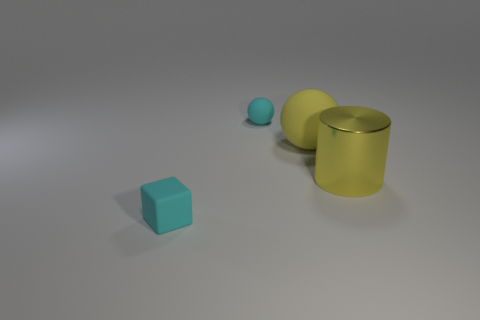Are there fewer big matte spheres that are to the right of the yellow rubber thing than cyan rubber cubes in front of the tiny block?
Give a very brief answer. No. Does the large yellow sphere have the same material as the tiny sphere?
Ensure brevity in your answer.  Yes. What size is the object that is both right of the small matte sphere and to the left of the shiny object?
Ensure brevity in your answer.  Large. The metal object that is the same size as the yellow matte ball is what shape?
Make the answer very short. Cylinder. What is the material of the cyan object in front of the tiny thing that is behind the rubber thing in front of the yellow rubber object?
Offer a terse response. Rubber. There is a cyan object that is in front of the large shiny object; is its shape the same as the tiny cyan rubber thing that is behind the small cube?
Provide a succinct answer. No. How many other things are the same material as the yellow ball?
Make the answer very short. 2. Does the tiny cyan block to the left of the yellow cylinder have the same material as the large yellow thing that is on the left side of the big yellow metallic thing?
Keep it short and to the point. Yes. There is a tiny cyan object that is the same material as the cyan ball; what is its shape?
Give a very brief answer. Cube. Is there anything else that is the same color as the large metallic object?
Give a very brief answer. Yes. 